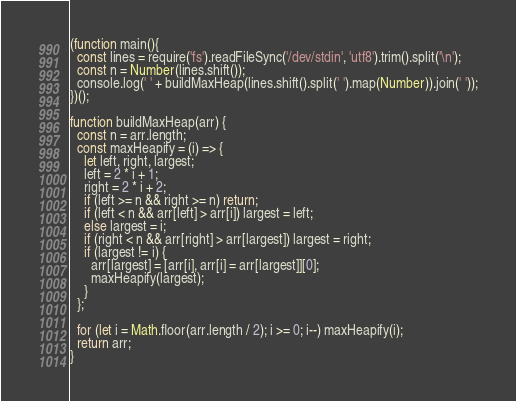<code> <loc_0><loc_0><loc_500><loc_500><_JavaScript_>(function main(){
  const lines = require('fs').readFileSync('/dev/stdin', 'utf8').trim().split('\n');
  const n = Number(lines.shift());
  console.log(' ' + buildMaxHeap(lines.shift().split(' ').map(Number)).join(' '));
})();

function buildMaxHeap(arr) {
  const n = arr.length;
  const maxHeapify = (i) => {
    let left, right, largest;
    left = 2 * i + 1;
    right = 2 * i + 2;
    if (left >= n && right >= n) return;
    if (left < n && arr[left] > arr[i]) largest = left;
    else largest = i;
    if (right < n && arr[right] > arr[largest]) largest = right;
    if (largest != i) {
      arr[largest] = [arr[i], arr[i] = arr[largest]][0];
      maxHeapify(largest);
    }
  };

  for (let i = Math.floor(arr.length / 2); i >= 0; i--) maxHeapify(i);
  return arr;
}

</code> 